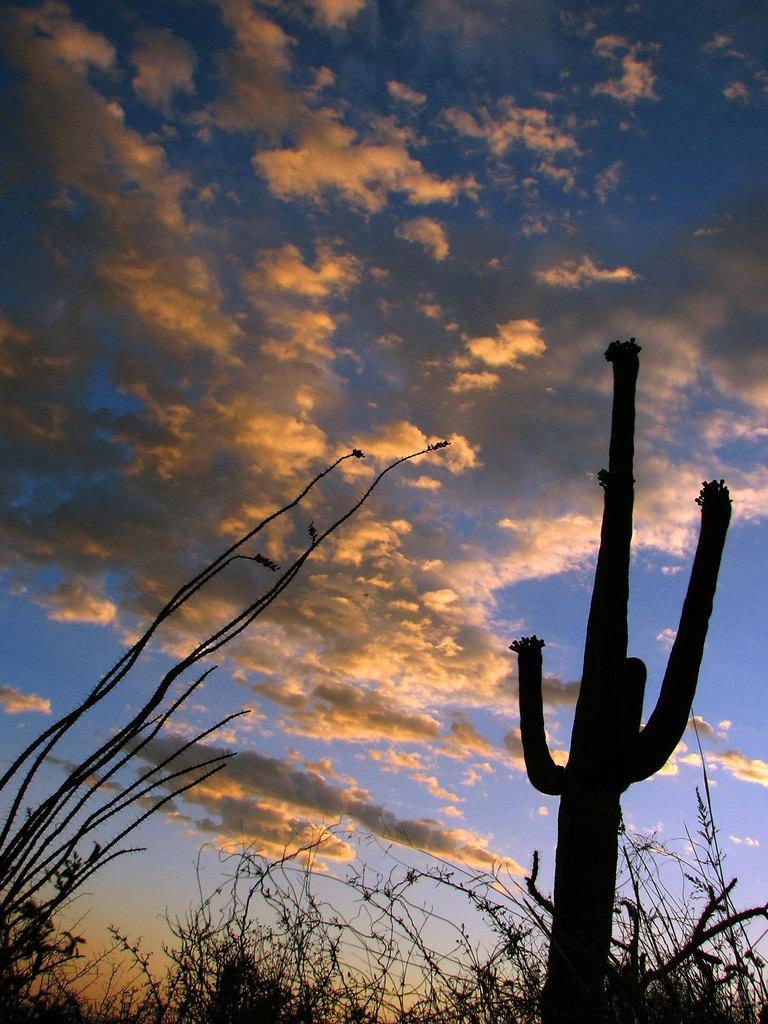What type of living organisms can be seen in the image? Plants can be seen in the image. What part of the natural environment is visible in the image? The sky is visible in the image. How would you describe the sky's condition in the image? The sky appears to be a bit cloudy in the image. What type of mass is being held by the kite in the image? There is no kite present in the image, so it is not possible to determine what type of mass might be held by a kite. 